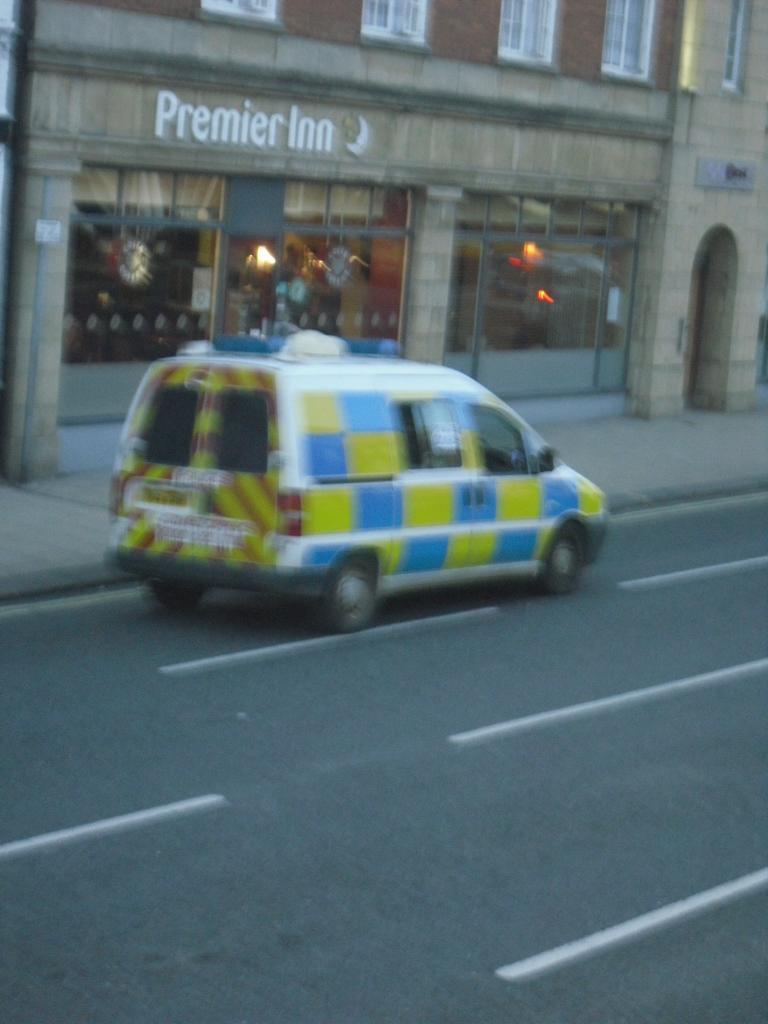Could you give a brief overview of what you see in this image? In this image I can see there is a car on the road. And at the side there is a building and windows. And there are a light and objects in it. 